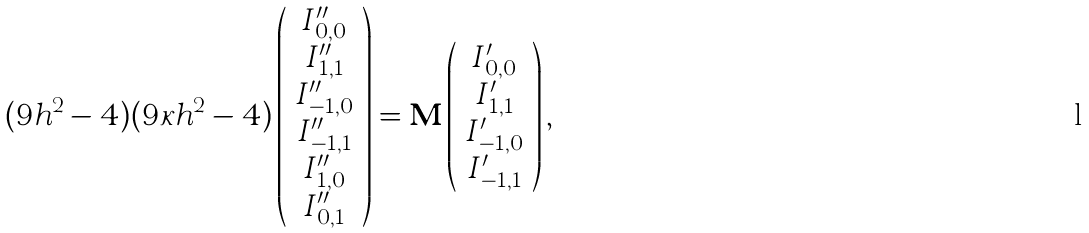<formula> <loc_0><loc_0><loc_500><loc_500>( 9 h ^ { 2 } - 4 ) ( 9 \kappa h ^ { 2 } - 4 ) \left ( \begin{array} { c } I _ { 0 , 0 } ^ { \prime \prime } \\ I _ { 1 , 1 } ^ { \prime \prime } \\ I _ { - 1 , 0 } ^ { \prime \prime } \\ I _ { - 1 , 1 } ^ { \prime \prime } \\ I _ { 1 , 0 } ^ { \prime \prime } \\ I _ { 0 , 1 } ^ { \prime \prime } \end{array} \right ) = { \mathbf M } \left ( \begin{array} { c } I _ { 0 , 0 } ^ { \prime } \\ I _ { 1 , 1 } ^ { \prime } \\ I _ { - 1 , 0 } ^ { \prime } \\ I _ { - 1 , 1 } ^ { \prime } \end{array} \right ) ,</formula> 